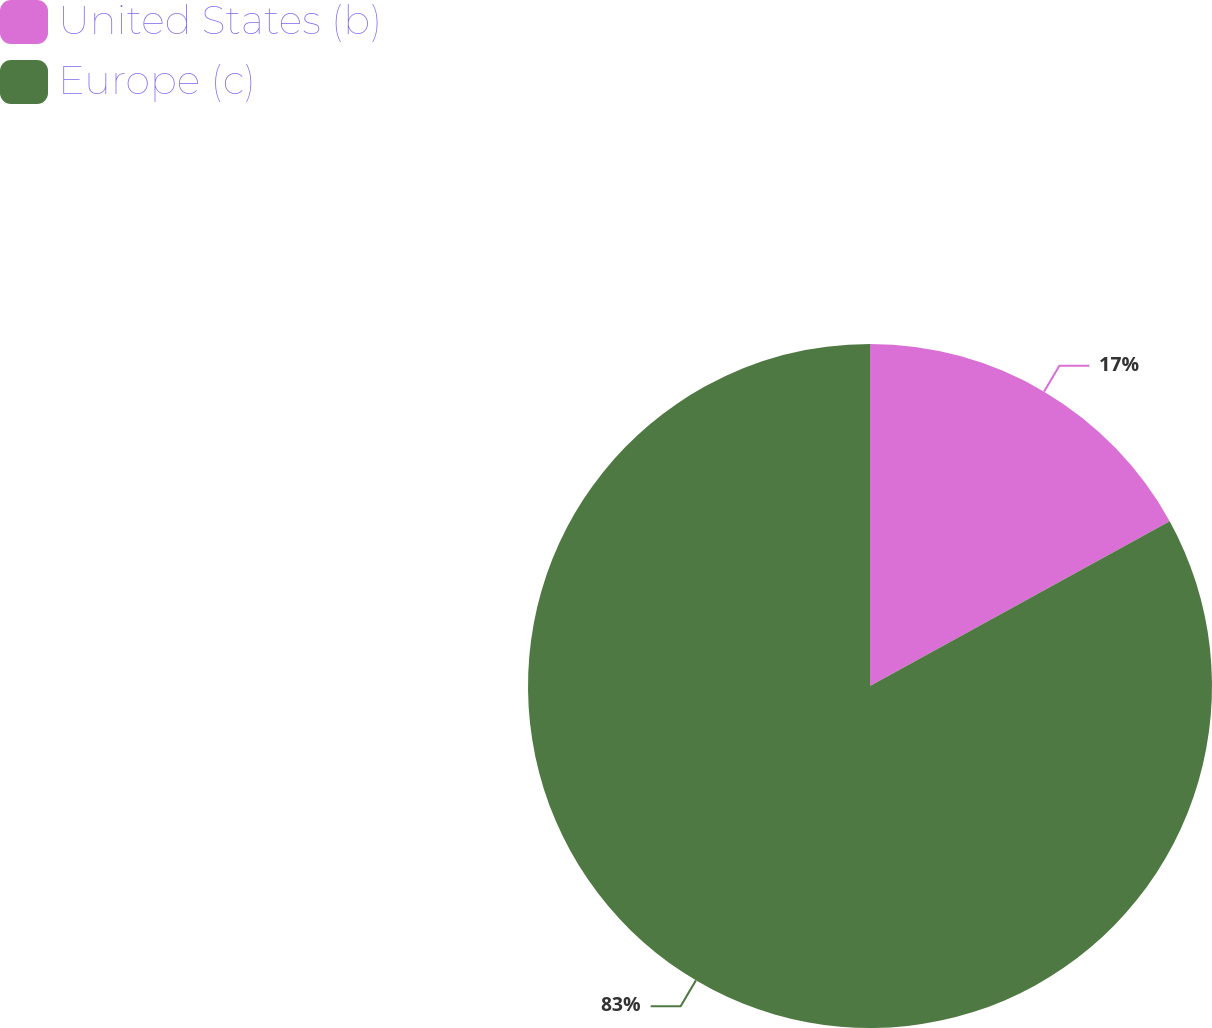Convert chart. <chart><loc_0><loc_0><loc_500><loc_500><pie_chart><fcel>United States (b)<fcel>Europe (c)<nl><fcel>17.0%<fcel>83.0%<nl></chart> 